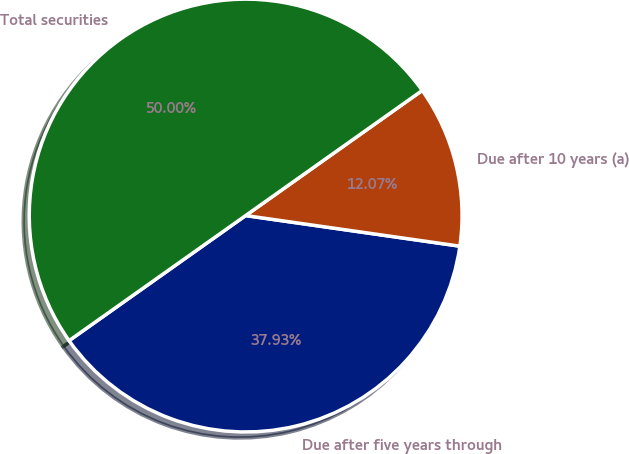Convert chart. <chart><loc_0><loc_0><loc_500><loc_500><pie_chart><fcel>Due after five years through<fcel>Due after 10 years (a)<fcel>Total securities<nl><fcel>37.93%<fcel>12.07%<fcel>50.0%<nl></chart> 